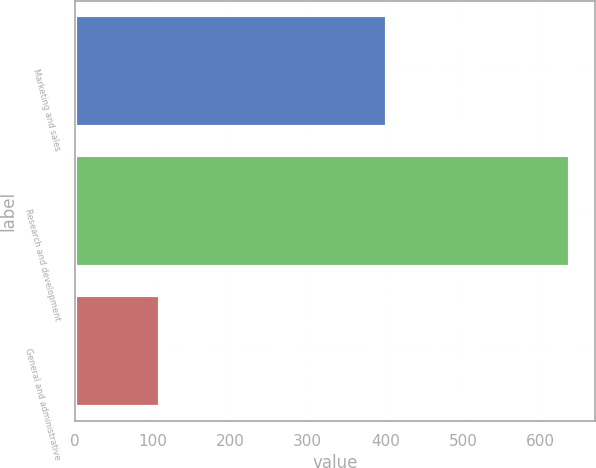Convert chart to OTSL. <chart><loc_0><loc_0><loc_500><loc_500><bar_chart><fcel>Marketing and sales<fcel>Research and development<fcel>General and administrative<nl><fcel>402.4<fcel>637.6<fcel>110<nl></chart> 